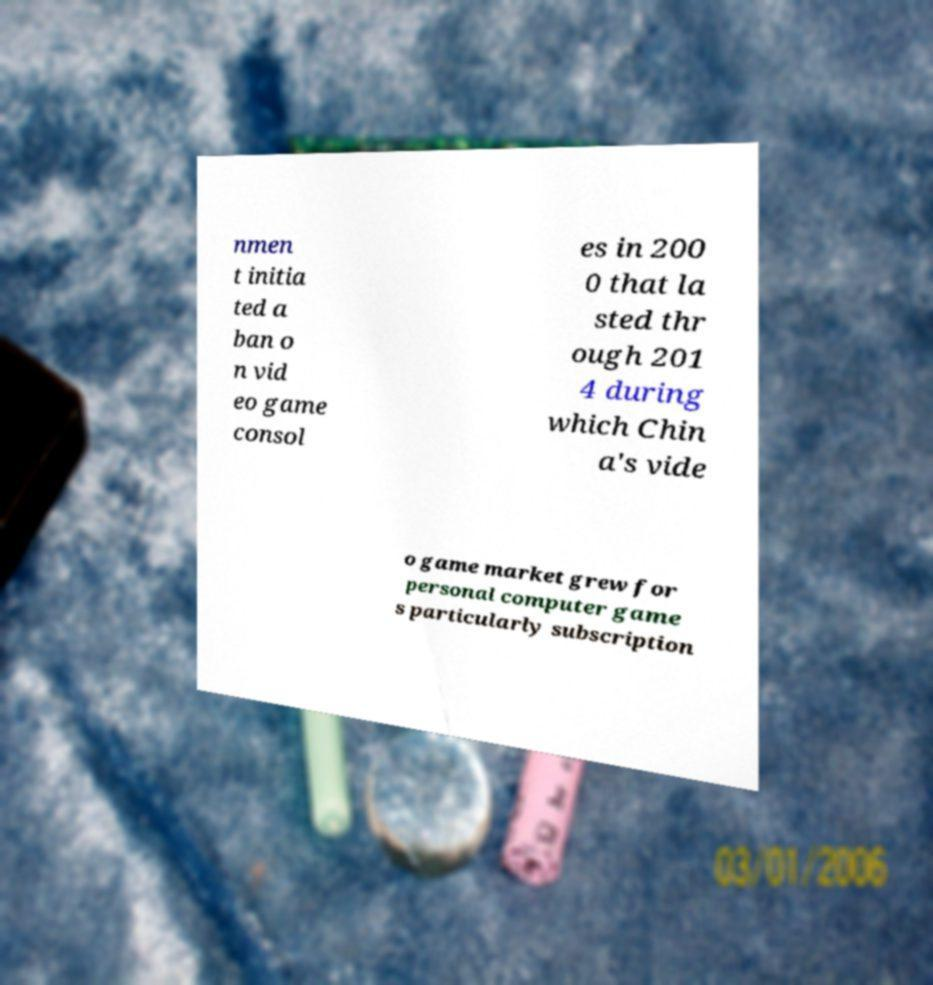Please read and relay the text visible in this image. What does it say? nmen t initia ted a ban o n vid eo game consol es in 200 0 that la sted thr ough 201 4 during which Chin a's vide o game market grew for personal computer game s particularly subscription 